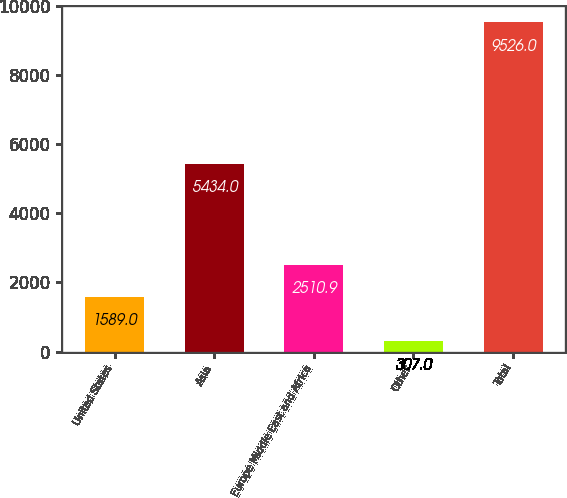Convert chart. <chart><loc_0><loc_0><loc_500><loc_500><bar_chart><fcel>United States<fcel>Asia<fcel>Europe Middle East and Africa<fcel>Other<fcel>Total<nl><fcel>1589<fcel>5434<fcel>2510.9<fcel>307<fcel>9526<nl></chart> 